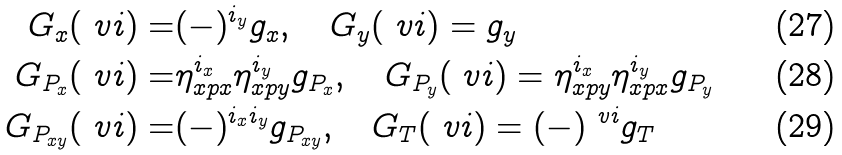Convert formula to latex. <formula><loc_0><loc_0><loc_500><loc_500>G _ { x } ( \ v i ) = & ( - ) ^ { i _ { y } } g _ { x } , \quad G _ { y } ( \ v i ) = g _ { y } \\ G _ { P _ { x } } ( \ v i ) = & \eta _ { x p x } ^ { i _ { x } } \eta _ { x p y } ^ { i _ { y } } g _ { P _ { x } } , \quad G _ { P _ { y } } ( \ v i ) = \eta _ { x p y } ^ { i _ { x } } \eta _ { x p x } ^ { i _ { y } } g _ { P _ { y } } \\ G _ { P _ { x y } } ( \ v i ) = & ( - ) ^ { i _ { x } i _ { y } } g _ { P _ { x y } } , \quad G _ { T } ( \ v i ) = ( - ) ^ { \ v i } g _ { T }</formula> 